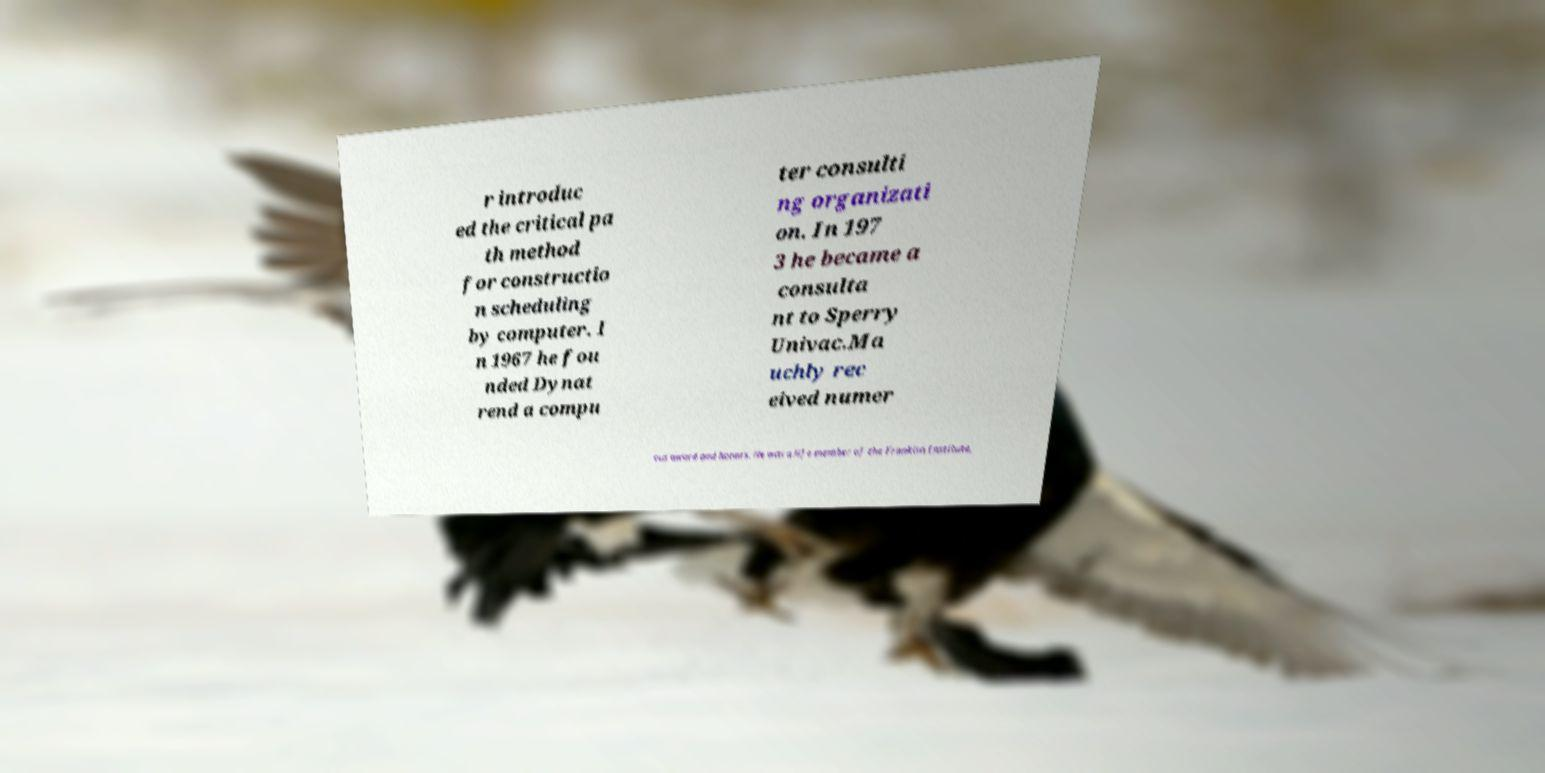I need the written content from this picture converted into text. Can you do that? r introduc ed the critical pa th method for constructio n scheduling by computer. I n 1967 he fou nded Dynat rend a compu ter consulti ng organizati on. In 197 3 he became a consulta nt to Sperry Univac.Ma uchly rec eived numer ous award and honors. He was a life member of the Franklin Institute, 